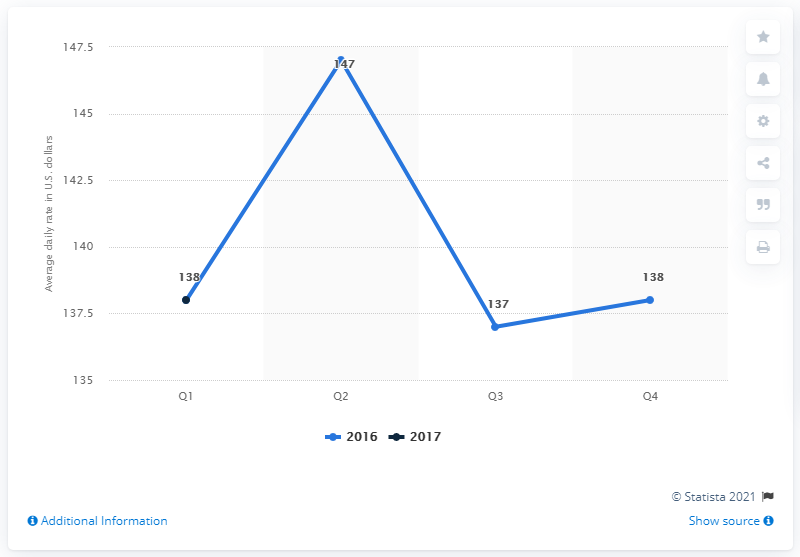Point out several critical features in this image. The average daily rate of hotels in Indianapolis in dollars during the first quarter of 2017 was 138. 